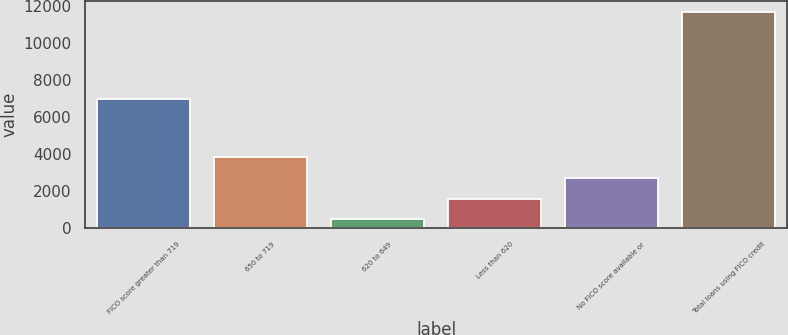Convert chart. <chart><loc_0><loc_0><loc_500><loc_500><bar_chart><fcel>FICO score greater than 719<fcel>650 to 719<fcel>620 to 649<fcel>Less than 620<fcel>No FICO score available or<fcel>Total loans using FICO credit<nl><fcel>7006<fcel>3832.5<fcel>459<fcel>1583.5<fcel>2708<fcel>11704<nl></chart> 